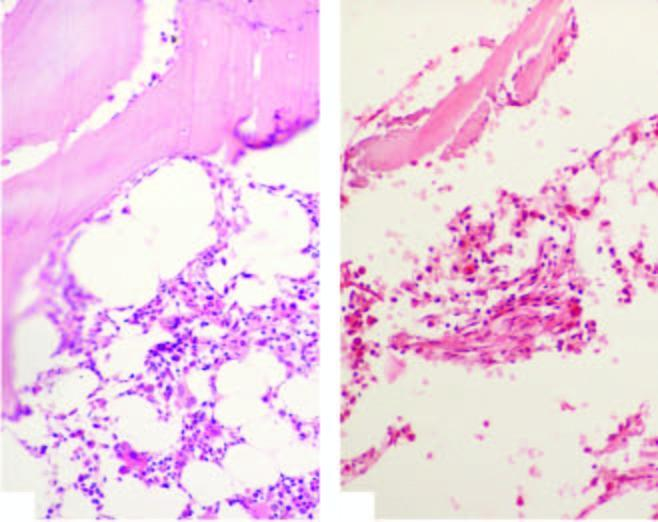what in aplastic anaemia is contrasted against normal cellular marrow?
Answer the question using a single word or phrase. Bone marrow trephine biopsy 